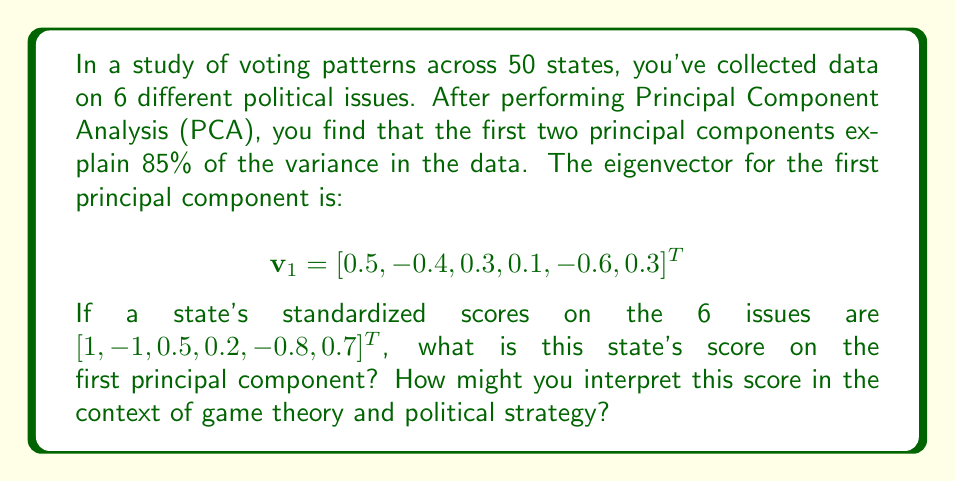Teach me how to tackle this problem. To solve this problem, we need to follow these steps:

1) Recall that the score on a principal component is the dot product of the data point and the eigenvector for that component.

2) Let's call the state's standardized scores $x$. So we have:

   $$x = [1, -1, 0.5, 0.2, -0.8, 0.7]^T$$

3) The score on the first principal component, let's call it $s_1$, is given by:

   $$s_1 = x^T v_1$$

4) Calculating this dot product:

   $$\begin{align}
   s_1 &= (1)(0.5) + (-1)(-0.4) + (0.5)(0.3) + (0.2)(0.1) + (-0.8)(-0.6) + (0.7)(0.3) \\
   &= 0.5 + 0.4 + 0.15 + 0.02 + 0.48 + 0.21 \\
   &= 1.76
   \end{align}$$

5) Interpreting this score in the context of game theory and political strategy:

   The positive score indicates that this state leans towards the positive end of the first principal component. In game theory terms, this suggests that the state's position on these issues might be seen as a "strategy" that aligns with one end of the main axis of variation in the data.

   Given that the first principal component often represents the most significant divide in the data, this could indicate the state's overall ideological leaning. A political strategist might use this information to tailor campaign messages or policy proposals to appeal to voters in this state.

   Furthermore, knowing that this component explains a large portion of the variance (as part of the 85% explained by the first two components) suggests that understanding and addressing the issues represented by this component could be a dominant strategy in political games played out in this state.
Answer: The state's score on the first principal component is 1.76. 